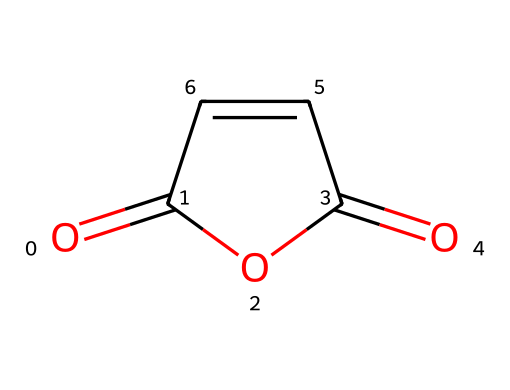What is the molecular formula of maleic anhydride? From the SMILES representation, we can derive the molecular formula by identifying the types and counts of each atom in the structure. The two carbonyl groups (C=O) and the carbon atoms in the ring contribute to a total of 4 carbon atoms, 4 hydrogen atoms, and 3 oxygen atoms. Thus, the molecular formula is C4H2O3.
Answer: C4H2O3 How many carbon atoms are present in the structure? By analyzing the SMILES representation, we see that there are four distinct carbon atoms present in the structure. Each 'C' in the SMILES corresponds to a carbon atom.
Answer: 4 What functional groups are present in maleic anhydride? The structure contains two carbonyl (C=O) groups and an anhydride linkage (the cyclic structure with oxygen), which are characteristic of anhydrides.
Answer: anhydride, carbonyl What type of reaction can maleic anhydride undergo? Given that maleic anhydride contains a highly reactive anhydride group, it can undergo hydrolysis when reacted with water, leading to the formation of maleic acid.
Answer: hydrolysis How many double bonds are in the maleic anhydride structure? In the provided structure, there are two double bonds: one in the carbonyl and another in the carbon-carbon bond within the ring. Thus, counting these gives a total of two double bonds.
Answer: 2 What is the significance of maleic anhydride in modern adhesives? Maleic anhydride is significant in adhesives due to its ability to form strong bonds and cross-links when utilized in polymer formulations, enhancing durability and resistance in restoration applications.
Answer: cross-linking What is the bond nature between carbon atoms in maleic anhydride? The bond nature between the carbon atoms includes both single and double bonds, where two carbon atoms are connected via a double bond and the others by single bonds to the carbonyl and the anhydride structure.
Answer: single, double 